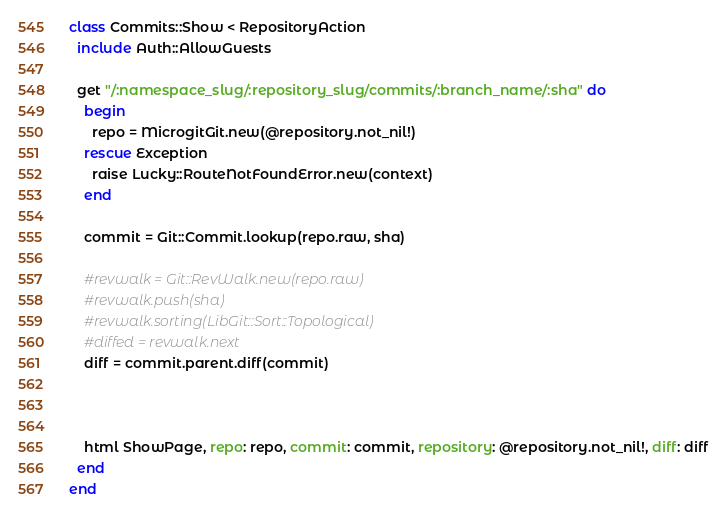<code> <loc_0><loc_0><loc_500><loc_500><_Crystal_>class Commits::Show < RepositoryAction
  include Auth::AllowGuests

  get "/:namespace_slug/:repository_slug/commits/:branch_name/:sha" do
    begin
      repo = MicrogitGit.new(@repository.not_nil!)
    rescue Exception
      raise Lucky::RouteNotFoundError.new(context)
    end

    commit = Git::Commit.lookup(repo.raw, sha)

    #revwalk = Git::RevWalk.new(repo.raw)
    #revwalk.push(sha)
    #revwalk.sorting(LibGit::Sort::Topological)
    #diffed = revwalk.next
    diff = commit.parent.diff(commit)



    html ShowPage, repo: repo, commit: commit, repository: @repository.not_nil!, diff: diff
  end
end
</code> 